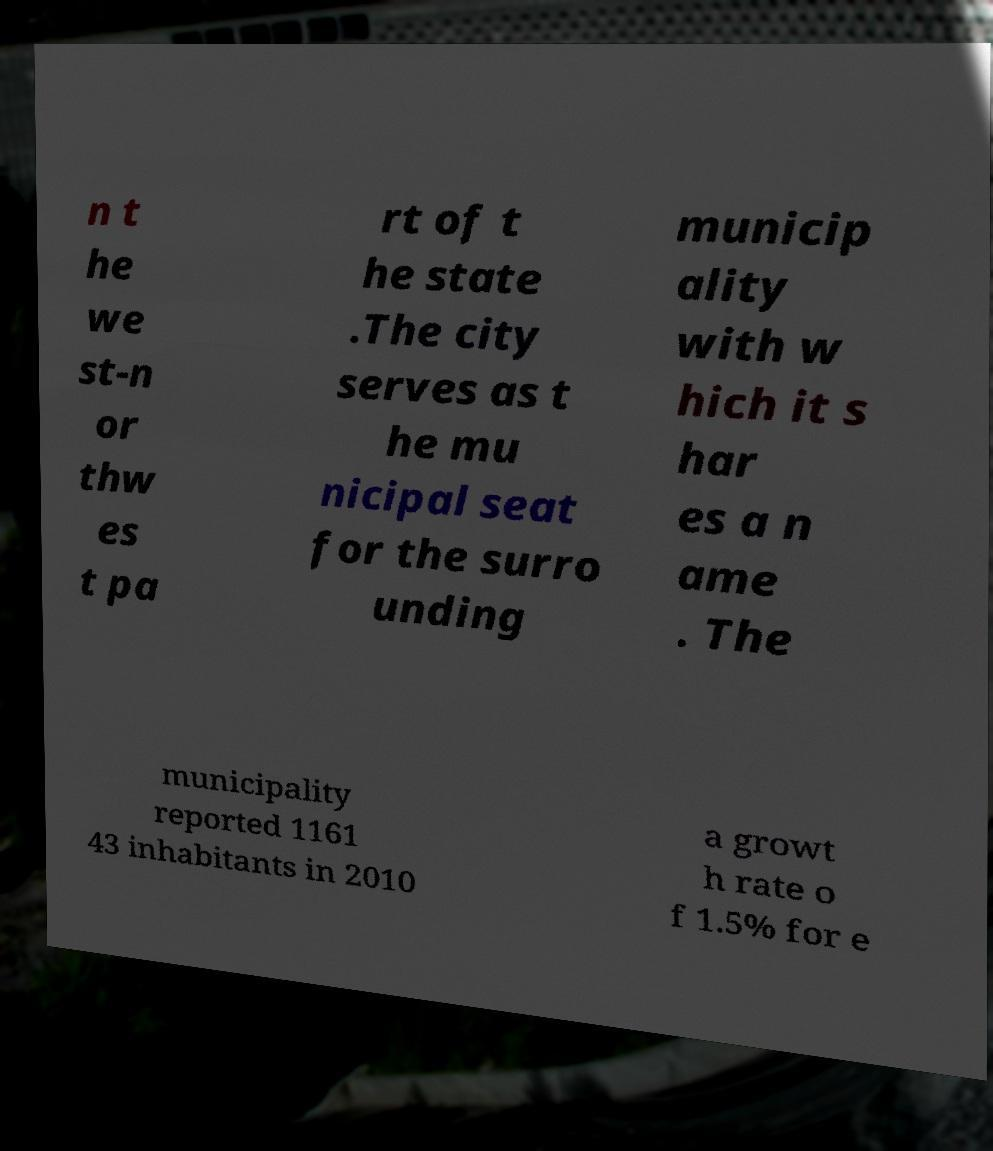Please read and relay the text visible in this image. What does it say? n t he we st-n or thw es t pa rt of t he state .The city serves as t he mu nicipal seat for the surro unding municip ality with w hich it s har es a n ame . The municipality reported 1161 43 inhabitants in 2010 a growt h rate o f 1.5% for e 